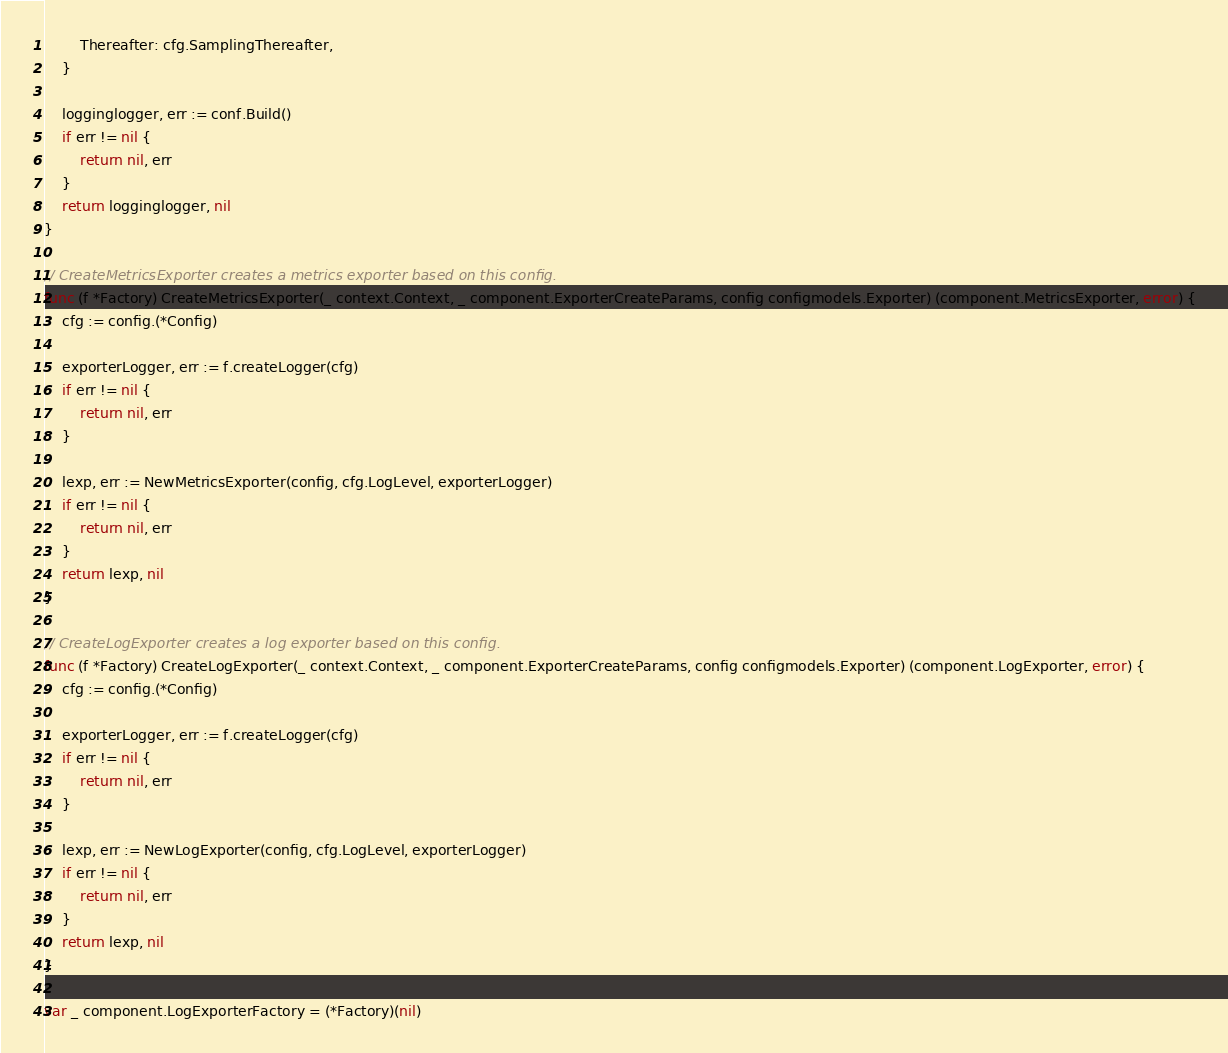Convert code to text. <code><loc_0><loc_0><loc_500><loc_500><_Go_>		Thereafter: cfg.SamplingThereafter,
	}

	logginglogger, err := conf.Build()
	if err != nil {
		return nil, err
	}
	return logginglogger, nil
}

// CreateMetricsExporter creates a metrics exporter based on this config.
func (f *Factory) CreateMetricsExporter(_ context.Context, _ component.ExporterCreateParams, config configmodels.Exporter) (component.MetricsExporter, error) {
	cfg := config.(*Config)

	exporterLogger, err := f.createLogger(cfg)
	if err != nil {
		return nil, err
	}

	lexp, err := NewMetricsExporter(config, cfg.LogLevel, exporterLogger)
	if err != nil {
		return nil, err
	}
	return lexp, nil
}

// CreateLogExporter creates a log exporter based on this config.
func (f *Factory) CreateLogExporter(_ context.Context, _ component.ExporterCreateParams, config configmodels.Exporter) (component.LogExporter, error) {
	cfg := config.(*Config)

	exporterLogger, err := f.createLogger(cfg)
	if err != nil {
		return nil, err
	}

	lexp, err := NewLogExporter(config, cfg.LogLevel, exporterLogger)
	if err != nil {
		return nil, err
	}
	return lexp, nil
}

var _ component.LogExporterFactory = (*Factory)(nil)
</code> 